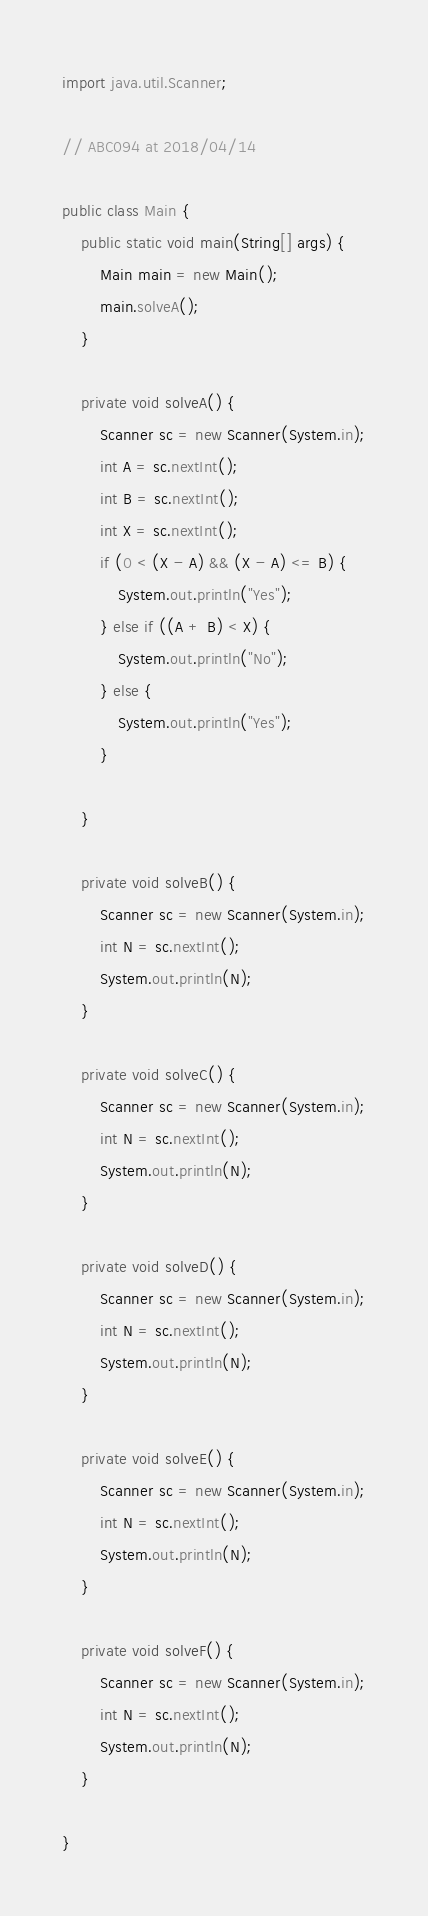<code> <loc_0><loc_0><loc_500><loc_500><_Java_>
import java.util.Scanner;

// ABC094 at 2018/04/14

public class Main {
    public static void main(String[] args) {
        Main main = new Main();
        main.solveA();
    }

    private void solveA() {
        Scanner sc = new Scanner(System.in);
        int A = sc.nextInt();
        int B = sc.nextInt();
        int X = sc.nextInt();
        if (0 < (X - A) && (X - A) <= B) {
            System.out.println("Yes");
        } else if ((A + B) < X) {
            System.out.println("No");
        } else {
            System.out.println("Yes");
        }

    }

    private void solveB() {
        Scanner sc = new Scanner(System.in);
        int N = sc.nextInt();
        System.out.println(N);
    }

    private void solveC() {
        Scanner sc = new Scanner(System.in);
        int N = sc.nextInt();
        System.out.println(N);
    }

    private void solveD() {
        Scanner sc = new Scanner(System.in);
        int N = sc.nextInt();
        System.out.println(N);
    }

    private void solveE() {
        Scanner sc = new Scanner(System.in);
        int N = sc.nextInt();
        System.out.println(N);
    }

    private void solveF() {
        Scanner sc = new Scanner(System.in);
        int N = sc.nextInt();
        System.out.println(N);
    }

}</code> 